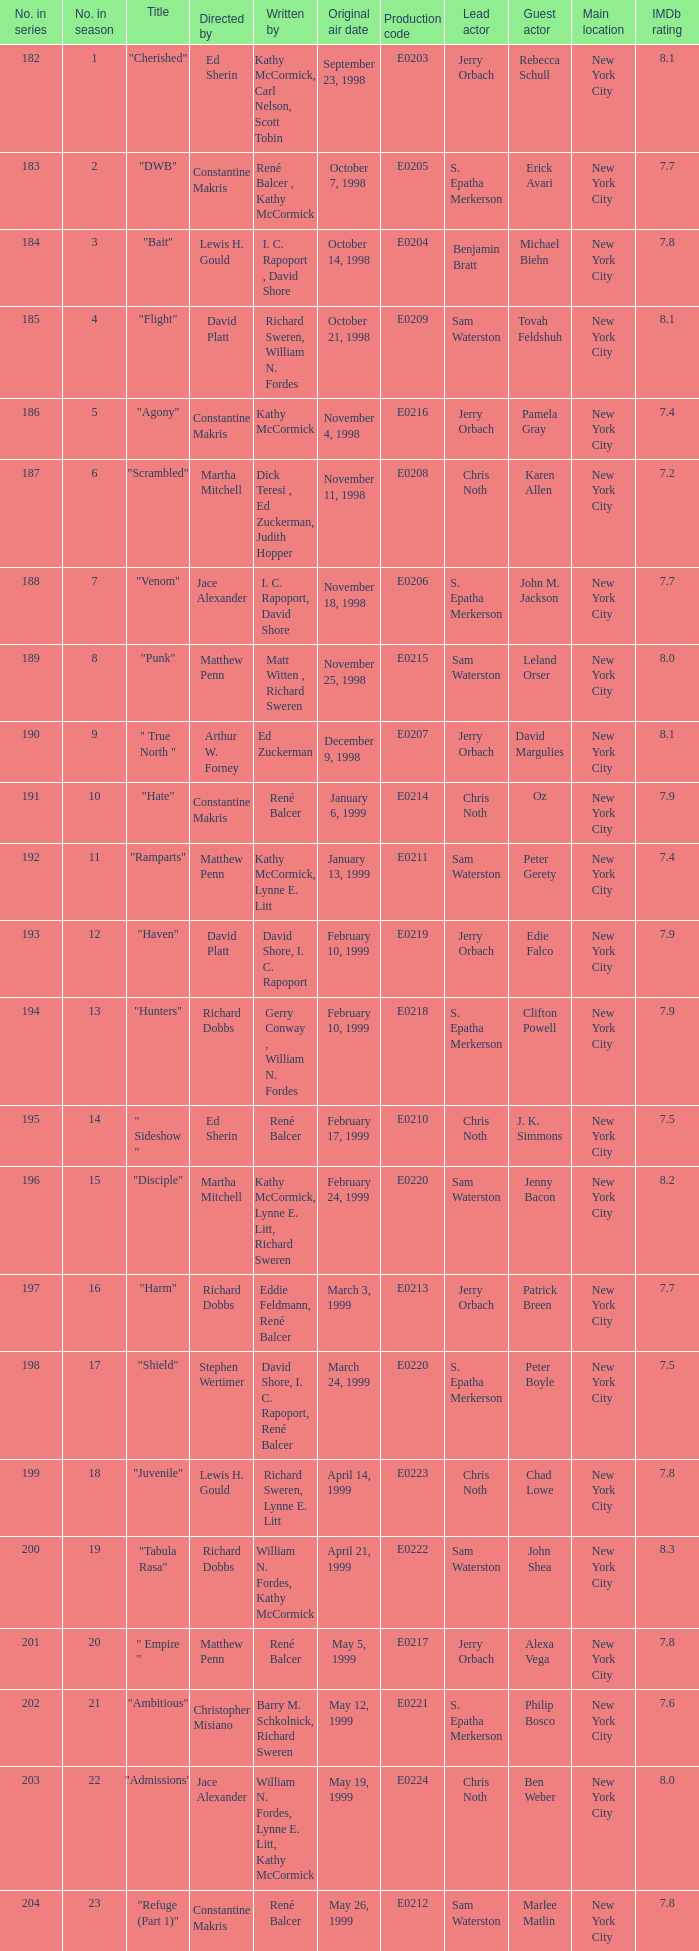The episode with the original air date January 6, 1999, has what production code? E0214. 